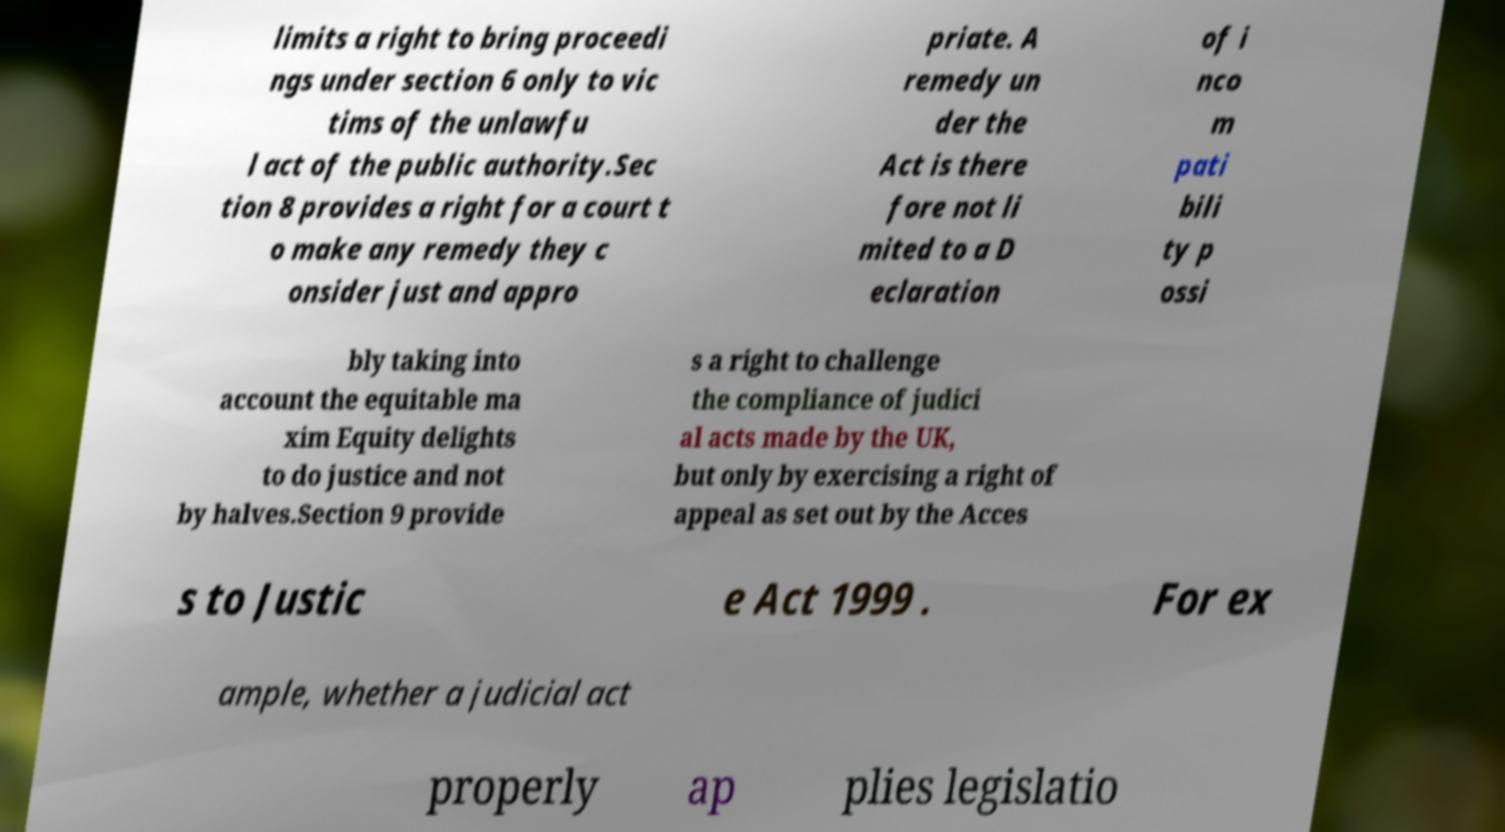Please identify and transcribe the text found in this image. limits a right to bring proceedi ngs under section 6 only to vic tims of the unlawfu l act of the public authority.Sec tion 8 provides a right for a court t o make any remedy they c onsider just and appro priate. A remedy un der the Act is there fore not li mited to a D eclaration of i nco m pati bili ty p ossi bly taking into account the equitable ma xim Equity delights to do justice and not by halves.Section 9 provide s a right to challenge the compliance of judici al acts made by the UK, but only by exercising a right of appeal as set out by the Acces s to Justic e Act 1999 . For ex ample, whether a judicial act properly ap plies legislatio 